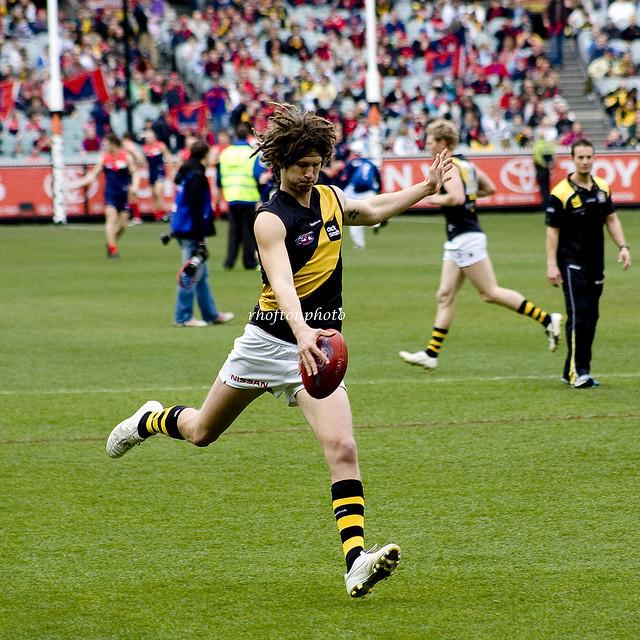Which sport is this?
Be succinct. Football. What sport is this?
Answer briefly. Rugby. What shoes color are the same?
Give a very brief answer. White. What color is the ball?
Quick response, please. Brown. What sport do these men play?
Be succinct. Rugby. Is he about to kick or throw the ball?
Write a very short answer. Kick. What color are they socks?
Concise answer only. Black and yellow. What is in the man's hands?
Answer briefly. Football. What kind of ball are they chasing?
Keep it brief. Football. 